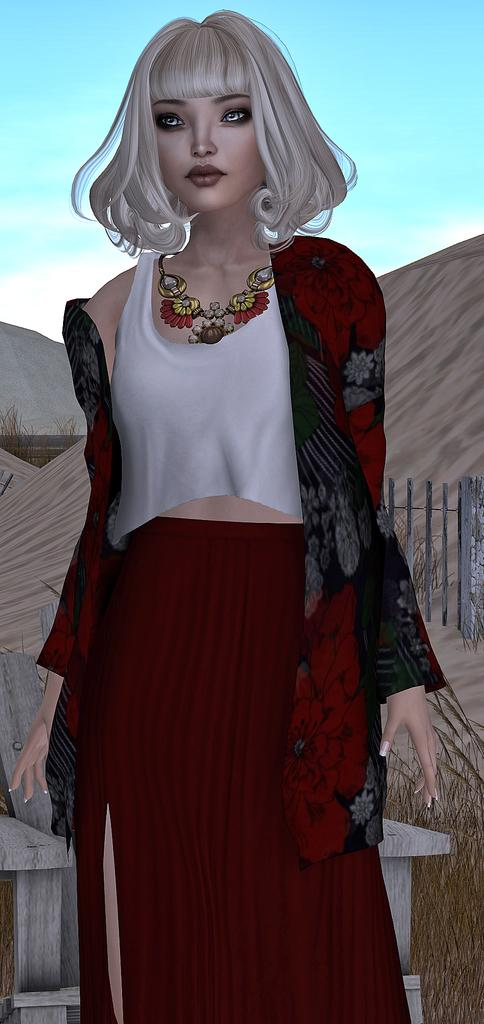What type of picture is the image? The image is an animated picture. Who or what can be seen in the image? There is a woman standing in the image. What type of terrain is visible in the image? There is grass visible in the image. What type of furniture is present in the image? There is a chair in the image. What type of barrier is present in the image? There is a fence in the image. What type of geographical feature is visible in the image? There are hills in the image. What is visible in the background of the image? The sky is visible in the background of the image. What type of rice is being cooked in the image? There is no rice present in the image. What type of building can be seen in the background of the image? There is no building visible in the image; only hills and the sky are present in the background. 